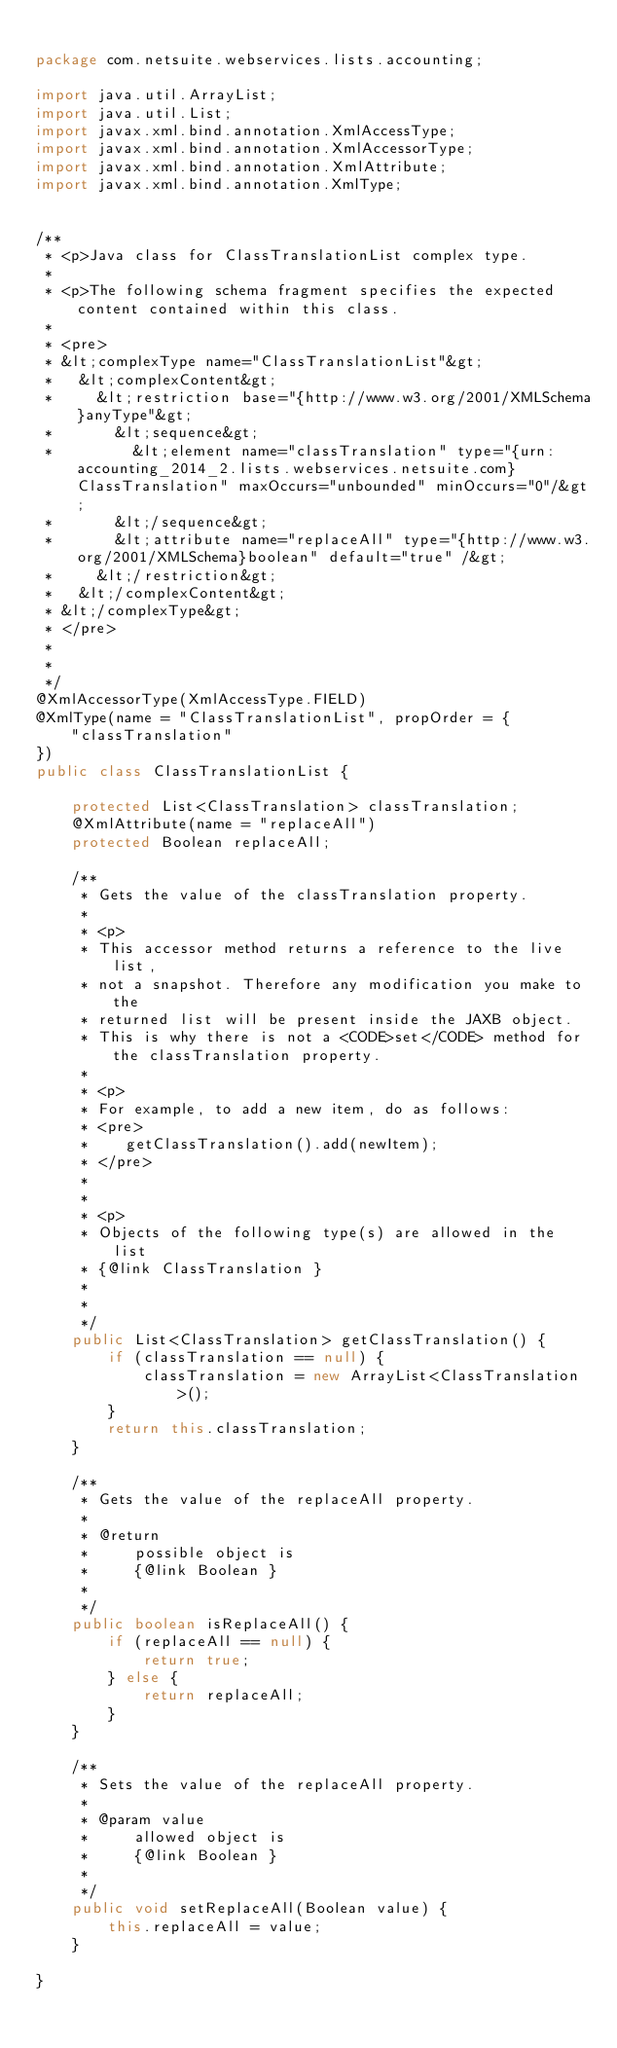<code> <loc_0><loc_0><loc_500><loc_500><_Java_>
package com.netsuite.webservices.lists.accounting;

import java.util.ArrayList;
import java.util.List;
import javax.xml.bind.annotation.XmlAccessType;
import javax.xml.bind.annotation.XmlAccessorType;
import javax.xml.bind.annotation.XmlAttribute;
import javax.xml.bind.annotation.XmlType;


/**
 * <p>Java class for ClassTranslationList complex type.
 * 
 * <p>The following schema fragment specifies the expected content contained within this class.
 * 
 * <pre>
 * &lt;complexType name="ClassTranslationList"&gt;
 *   &lt;complexContent&gt;
 *     &lt;restriction base="{http://www.w3.org/2001/XMLSchema}anyType"&gt;
 *       &lt;sequence&gt;
 *         &lt;element name="classTranslation" type="{urn:accounting_2014_2.lists.webservices.netsuite.com}ClassTranslation" maxOccurs="unbounded" minOccurs="0"/&gt;
 *       &lt;/sequence&gt;
 *       &lt;attribute name="replaceAll" type="{http://www.w3.org/2001/XMLSchema}boolean" default="true" /&gt;
 *     &lt;/restriction&gt;
 *   &lt;/complexContent&gt;
 * &lt;/complexType&gt;
 * </pre>
 * 
 * 
 */
@XmlAccessorType(XmlAccessType.FIELD)
@XmlType(name = "ClassTranslationList", propOrder = {
    "classTranslation"
})
public class ClassTranslationList {

    protected List<ClassTranslation> classTranslation;
    @XmlAttribute(name = "replaceAll")
    protected Boolean replaceAll;

    /**
     * Gets the value of the classTranslation property.
     * 
     * <p>
     * This accessor method returns a reference to the live list,
     * not a snapshot. Therefore any modification you make to the
     * returned list will be present inside the JAXB object.
     * This is why there is not a <CODE>set</CODE> method for the classTranslation property.
     * 
     * <p>
     * For example, to add a new item, do as follows:
     * <pre>
     *    getClassTranslation().add(newItem);
     * </pre>
     * 
     * 
     * <p>
     * Objects of the following type(s) are allowed in the list
     * {@link ClassTranslation }
     * 
     * 
     */
    public List<ClassTranslation> getClassTranslation() {
        if (classTranslation == null) {
            classTranslation = new ArrayList<ClassTranslation>();
        }
        return this.classTranslation;
    }

    /**
     * Gets the value of the replaceAll property.
     * 
     * @return
     *     possible object is
     *     {@link Boolean }
     *     
     */
    public boolean isReplaceAll() {
        if (replaceAll == null) {
            return true;
        } else {
            return replaceAll;
        }
    }

    /**
     * Sets the value of the replaceAll property.
     * 
     * @param value
     *     allowed object is
     *     {@link Boolean }
     *     
     */
    public void setReplaceAll(Boolean value) {
        this.replaceAll = value;
    }

}
</code> 